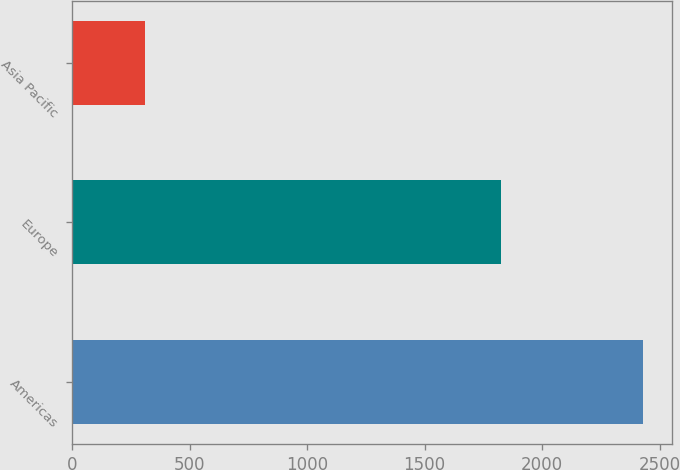Convert chart. <chart><loc_0><loc_0><loc_500><loc_500><bar_chart><fcel>Americas<fcel>Europe<fcel>Asia Pacific<nl><fcel>2430.9<fcel>1824.4<fcel>310.6<nl></chart> 